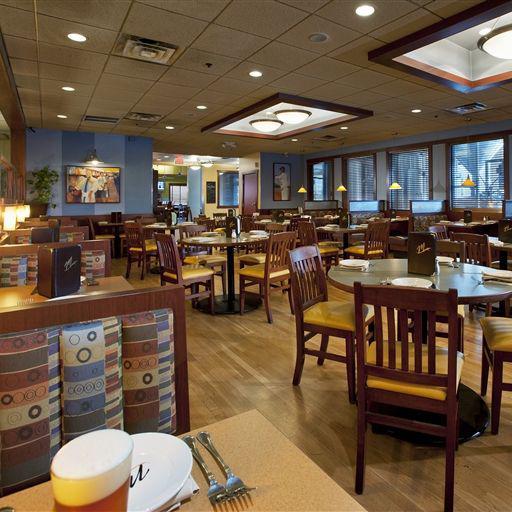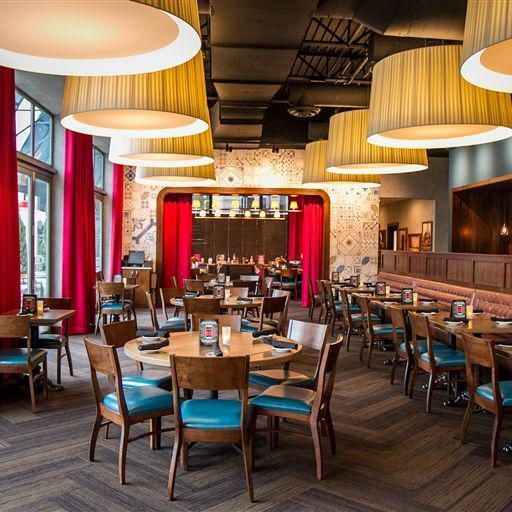The first image is the image on the left, the second image is the image on the right. Evaluate the accuracy of this statement regarding the images: "People are standing at the counter of the restaurant in one of the images.". Is it true? Answer yes or no. No. The first image is the image on the left, the second image is the image on the right. Given the left and right images, does the statement "One image has windows and the other does not." hold true? Answer yes or no. No. 